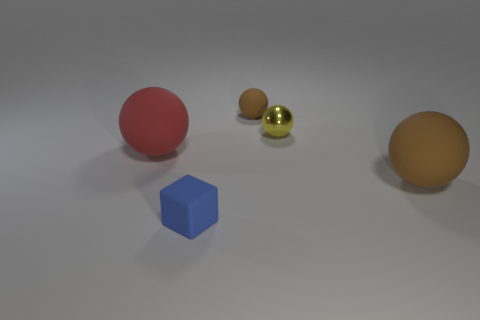How do the textures of these objects differ? Analyzing the image for texture, the small blue cube in the forefront appears to have a smooth, almost velvety surface. The large red sphere presents a texture that may remind one of a typical matte paint finish. The small gold sphere is highly reflective, suggesting a metallic texture, while the nearby tiny brown sphere has a rubbery look, with a slightly bumpy and diffused surface. Lastly, the large brown sphere on the right side exhibits a smooth, but not reflective surface, akin to a matte plastic finish. 